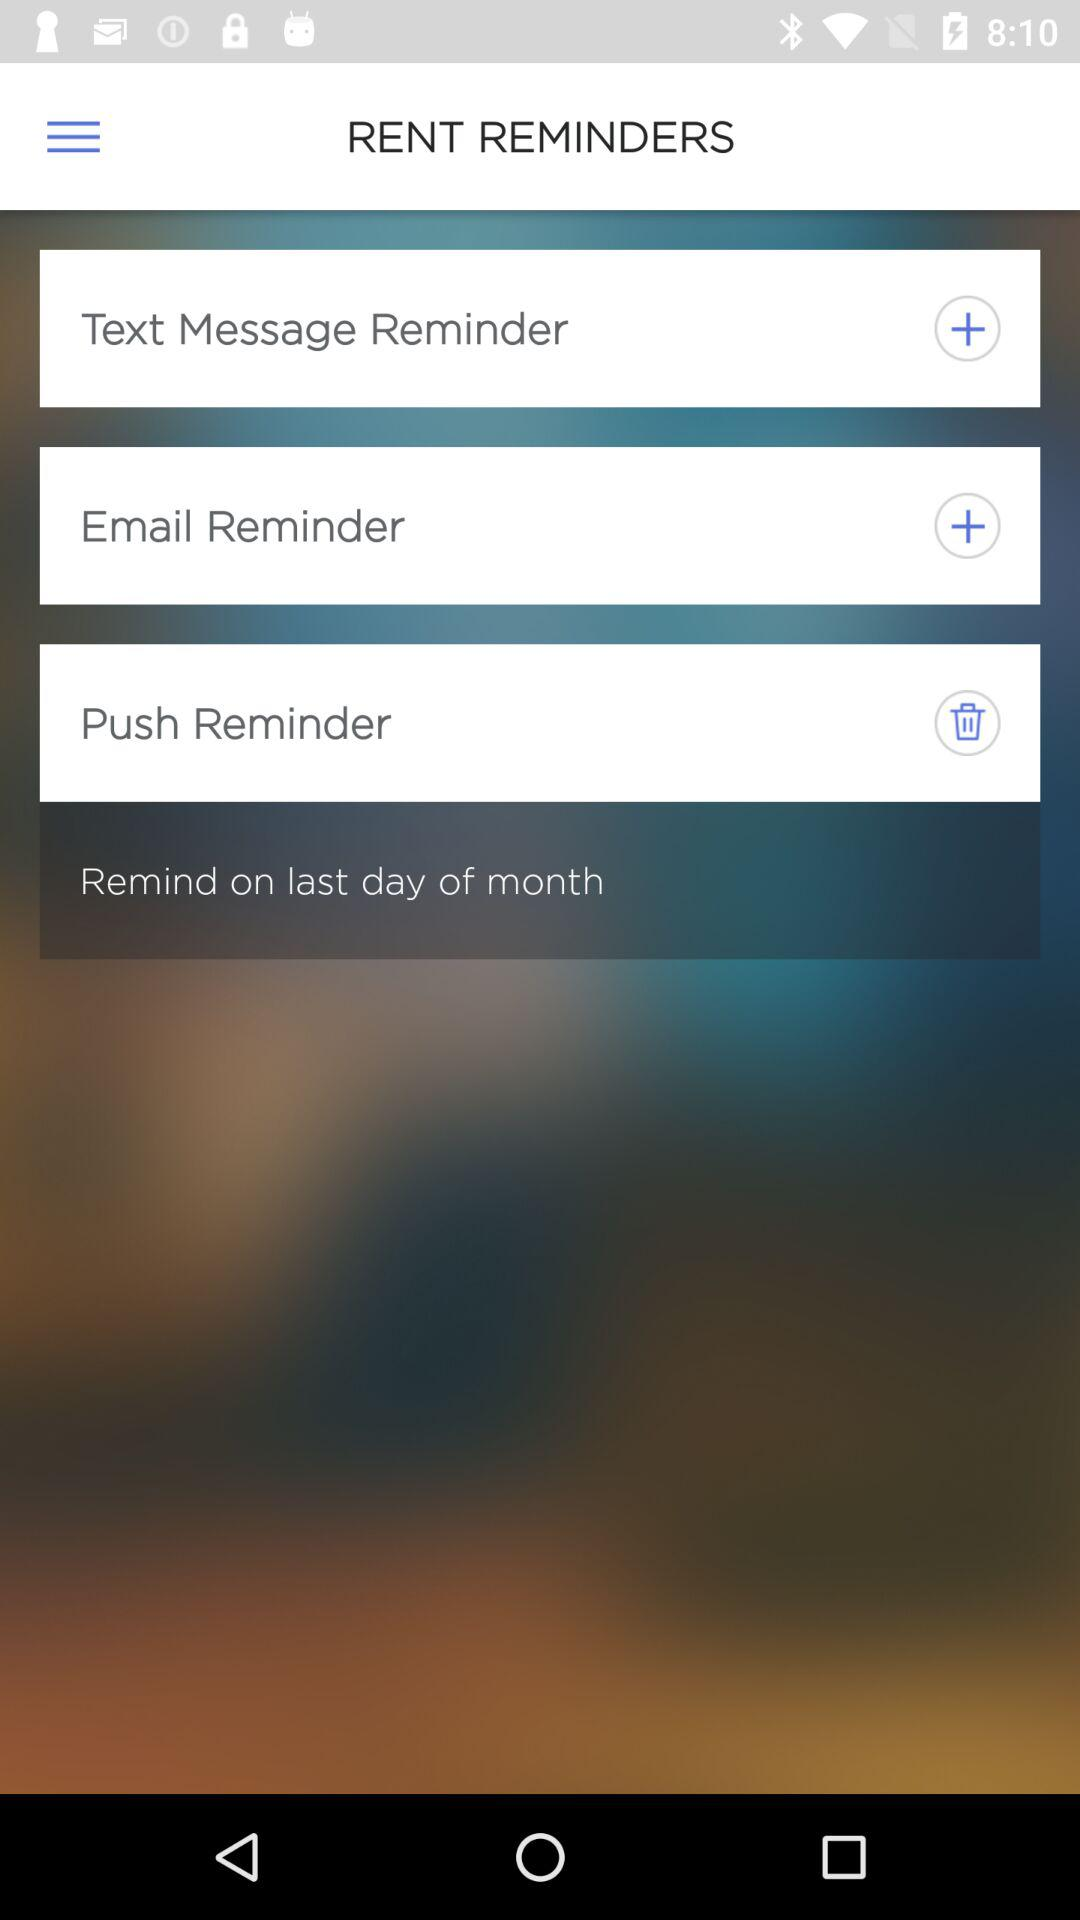Which types of reminders are there? The types of reminders are "Text Message", "Email" and "Push". 